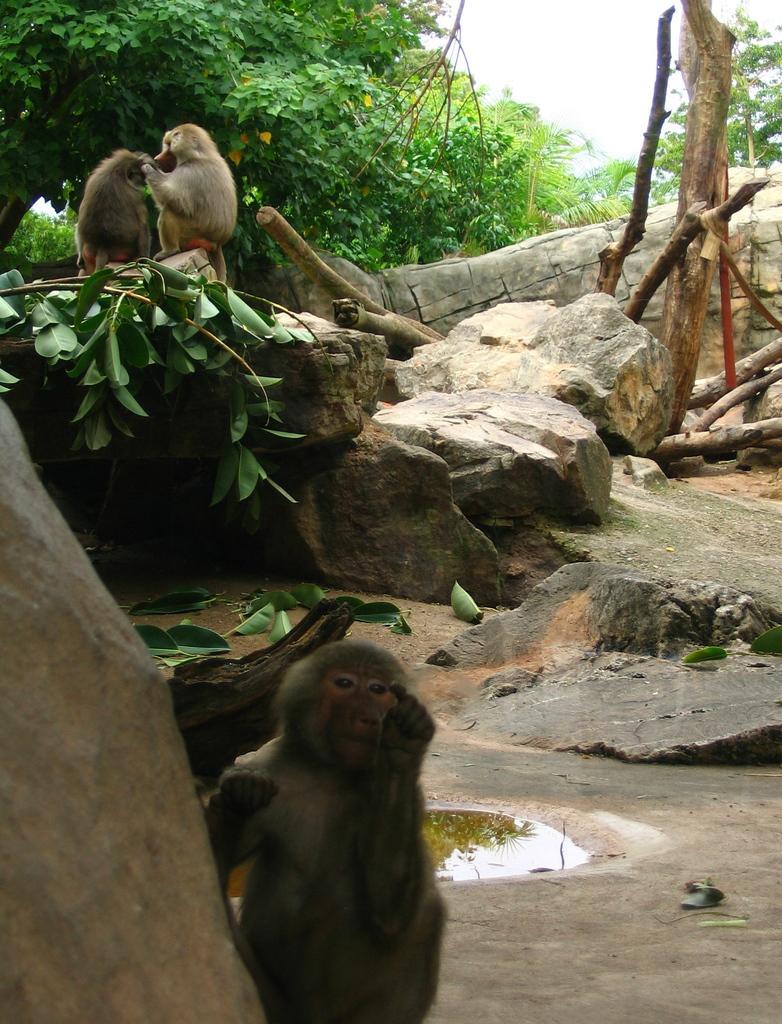Describe this image in one or two sentences. In this image we can see some monkeys, the rock's, some branches of a plant, some leaves on the ground, some water, a group of trees, some wooden logs and the sky. 